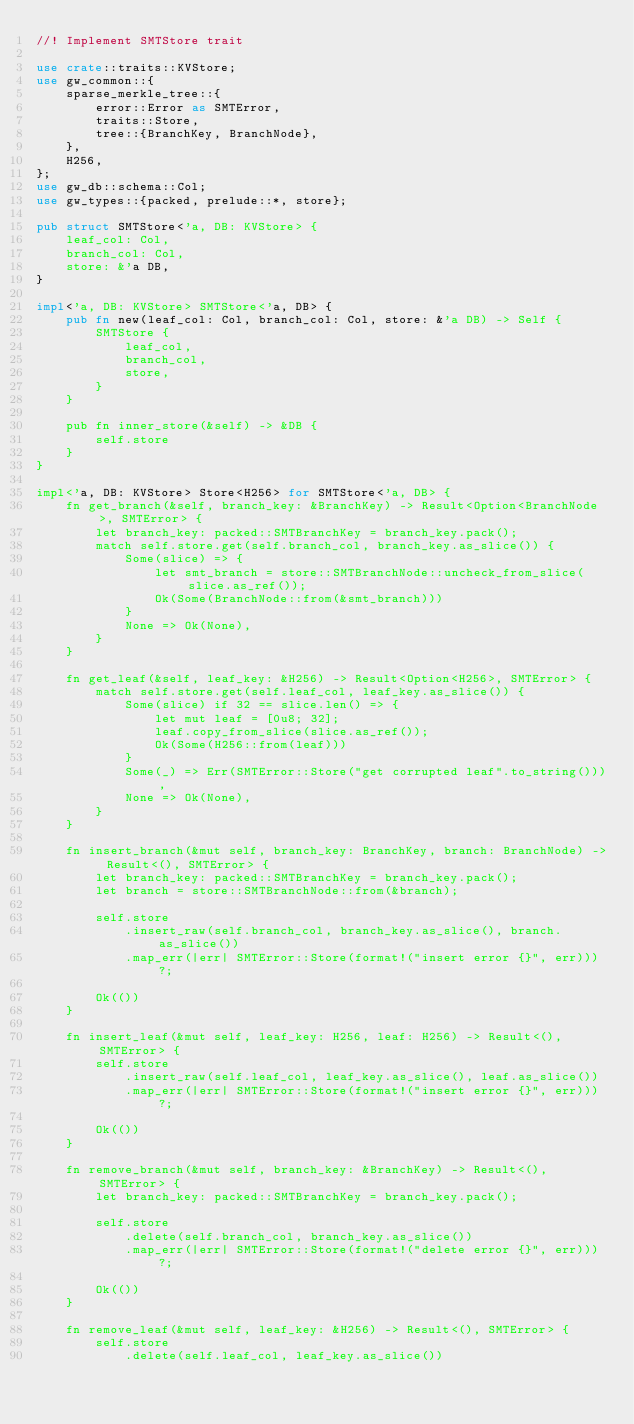Convert code to text. <code><loc_0><loc_0><loc_500><loc_500><_Rust_>//! Implement SMTStore trait

use crate::traits::KVStore;
use gw_common::{
    sparse_merkle_tree::{
        error::Error as SMTError,
        traits::Store,
        tree::{BranchKey, BranchNode},
    },
    H256,
};
use gw_db::schema::Col;
use gw_types::{packed, prelude::*, store};

pub struct SMTStore<'a, DB: KVStore> {
    leaf_col: Col,
    branch_col: Col,
    store: &'a DB,
}

impl<'a, DB: KVStore> SMTStore<'a, DB> {
    pub fn new(leaf_col: Col, branch_col: Col, store: &'a DB) -> Self {
        SMTStore {
            leaf_col,
            branch_col,
            store,
        }
    }

    pub fn inner_store(&self) -> &DB {
        self.store
    }
}

impl<'a, DB: KVStore> Store<H256> for SMTStore<'a, DB> {
    fn get_branch(&self, branch_key: &BranchKey) -> Result<Option<BranchNode>, SMTError> {
        let branch_key: packed::SMTBranchKey = branch_key.pack();
        match self.store.get(self.branch_col, branch_key.as_slice()) {
            Some(slice) => {
                let smt_branch = store::SMTBranchNode::uncheck_from_slice(slice.as_ref());
                Ok(Some(BranchNode::from(&smt_branch)))
            }
            None => Ok(None),
        }
    }

    fn get_leaf(&self, leaf_key: &H256) -> Result<Option<H256>, SMTError> {
        match self.store.get(self.leaf_col, leaf_key.as_slice()) {
            Some(slice) if 32 == slice.len() => {
                let mut leaf = [0u8; 32];
                leaf.copy_from_slice(slice.as_ref());
                Ok(Some(H256::from(leaf)))
            }
            Some(_) => Err(SMTError::Store("get corrupted leaf".to_string())),
            None => Ok(None),
        }
    }

    fn insert_branch(&mut self, branch_key: BranchKey, branch: BranchNode) -> Result<(), SMTError> {
        let branch_key: packed::SMTBranchKey = branch_key.pack();
        let branch = store::SMTBranchNode::from(&branch);

        self.store
            .insert_raw(self.branch_col, branch_key.as_slice(), branch.as_slice())
            .map_err(|err| SMTError::Store(format!("insert error {}", err)))?;

        Ok(())
    }

    fn insert_leaf(&mut self, leaf_key: H256, leaf: H256) -> Result<(), SMTError> {
        self.store
            .insert_raw(self.leaf_col, leaf_key.as_slice(), leaf.as_slice())
            .map_err(|err| SMTError::Store(format!("insert error {}", err)))?;

        Ok(())
    }

    fn remove_branch(&mut self, branch_key: &BranchKey) -> Result<(), SMTError> {
        let branch_key: packed::SMTBranchKey = branch_key.pack();

        self.store
            .delete(self.branch_col, branch_key.as_slice())
            .map_err(|err| SMTError::Store(format!("delete error {}", err)))?;

        Ok(())
    }

    fn remove_leaf(&mut self, leaf_key: &H256) -> Result<(), SMTError> {
        self.store
            .delete(self.leaf_col, leaf_key.as_slice())</code> 